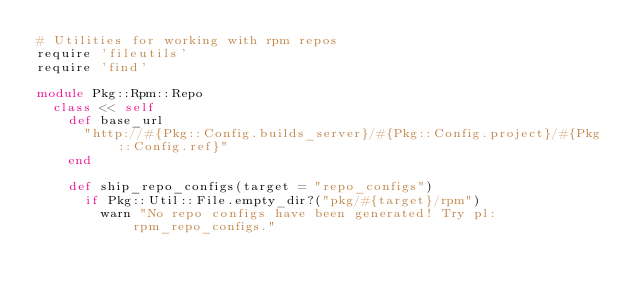Convert code to text. <code><loc_0><loc_0><loc_500><loc_500><_Ruby_># Utilities for working with rpm repos
require 'fileutils'
require 'find'

module Pkg::Rpm::Repo
  class << self
    def base_url
      "http://#{Pkg::Config.builds_server}/#{Pkg::Config.project}/#{Pkg::Config.ref}"
    end

    def ship_repo_configs(target = "repo_configs")
      if Pkg::Util::File.empty_dir?("pkg/#{target}/rpm")
        warn "No repo configs have been generated! Try pl:rpm_repo_configs."</code> 